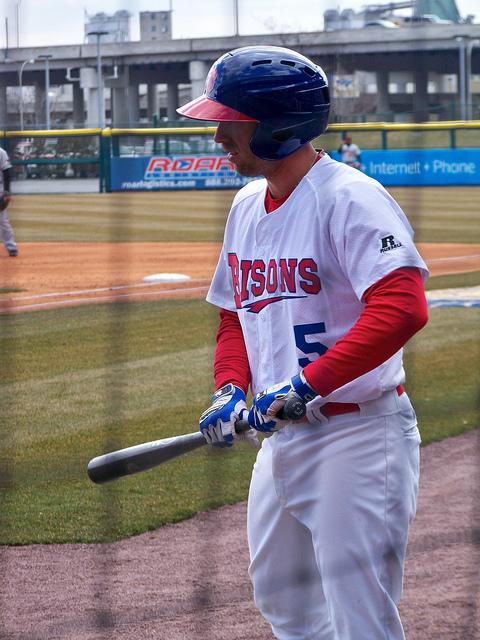Is the batter at bat?
Be succinct. No. Which sport is this?
Quick response, please. Baseball. What color are the men's gloves?
Answer briefly. Blue and white. What is his number?
Keep it brief. 5. Is this a photo of someone competing in the NBA?
Answer briefly. No. 